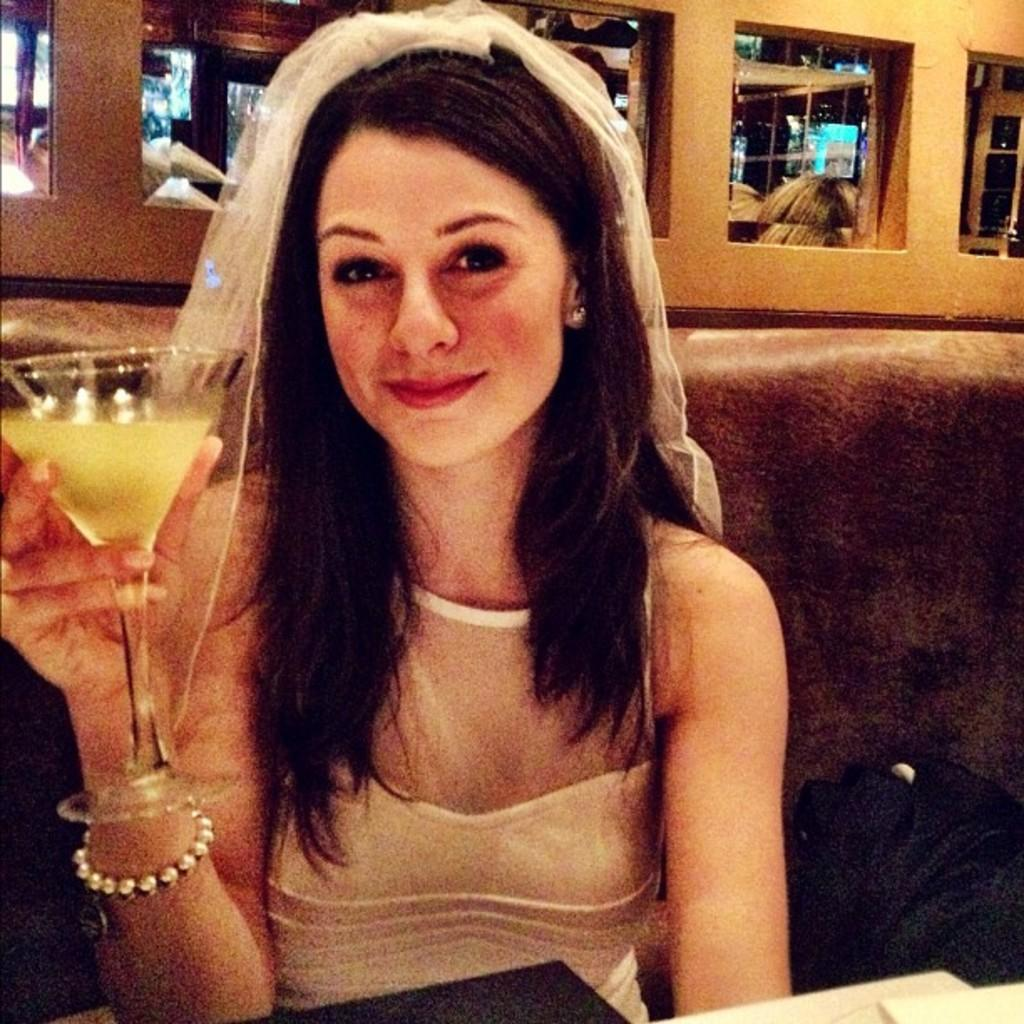What is the lady in the image doing? The lady is sitting in the image. What is the lady holding in the image? The lady is holding a glass. What can be seen on the right side of the image? There is a bag on the right side of the image. What is present in the background of the image? There are mirrors in the background of the image. What type of bell can be heard ringing in the image? There is no bell present in the image, and therefore no sound can be heard. 